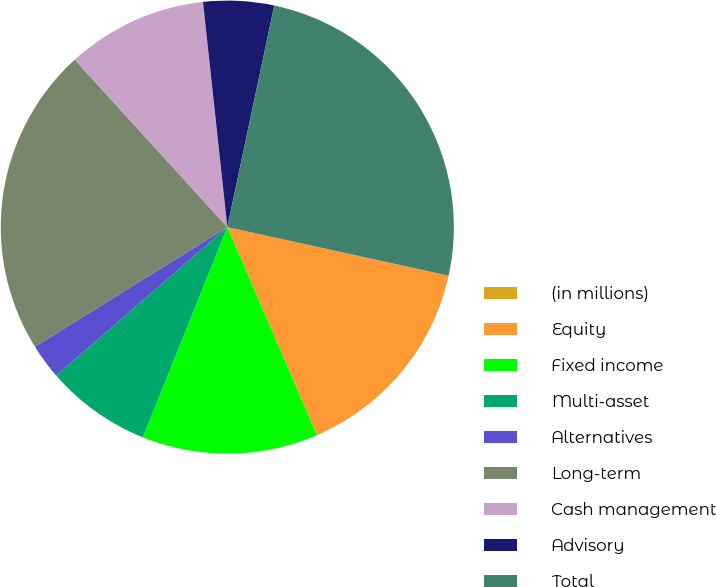Convert chart to OTSL. <chart><loc_0><loc_0><loc_500><loc_500><pie_chart><fcel>(in millions)<fcel>Equity<fcel>Fixed income<fcel>Multi-asset<fcel>Alternatives<fcel>Long-term<fcel>Cash management<fcel>Advisory<fcel>Total<nl><fcel>0.01%<fcel>15.07%<fcel>12.56%<fcel>7.54%<fcel>2.52%<fcel>22.08%<fcel>10.05%<fcel>5.03%<fcel>25.11%<nl></chart> 